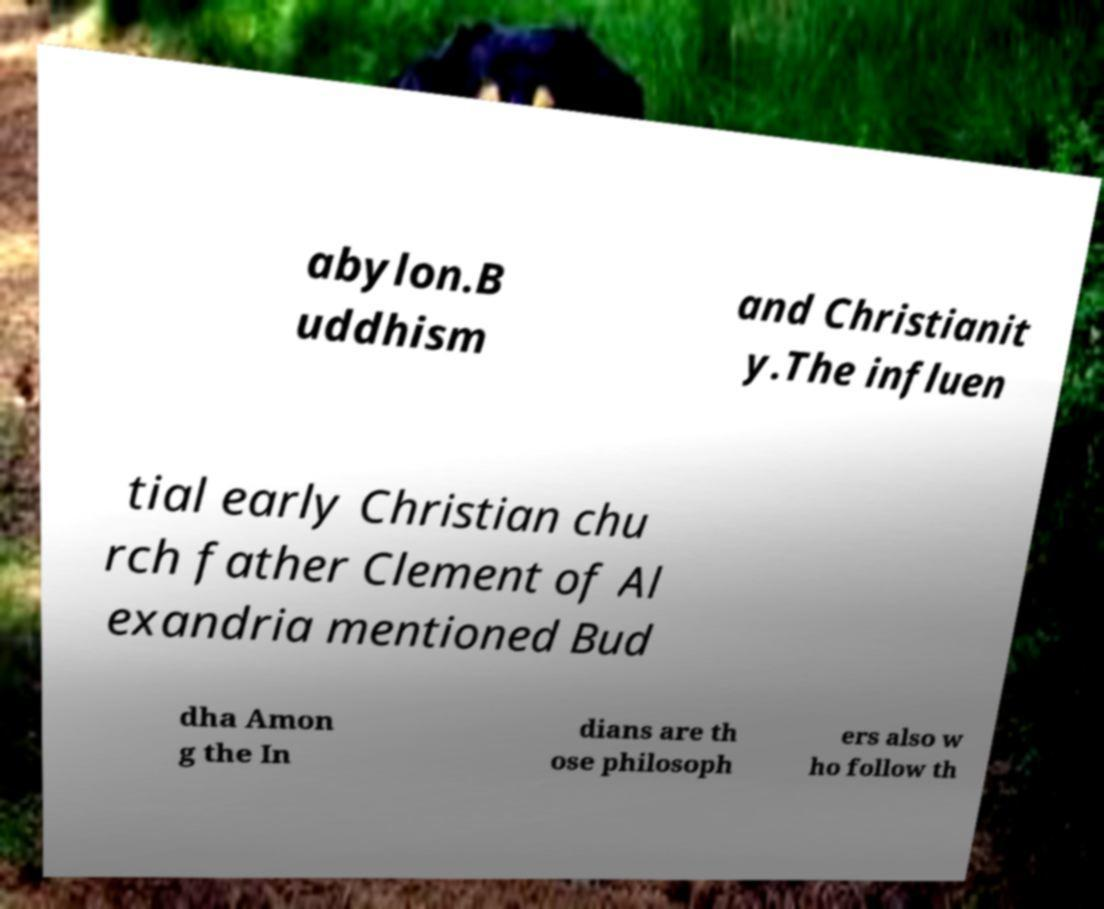Please read and relay the text visible in this image. What does it say? abylon.B uddhism and Christianit y.The influen tial early Christian chu rch father Clement of Al exandria mentioned Bud dha Amon g the In dians are th ose philosoph ers also w ho follow th 